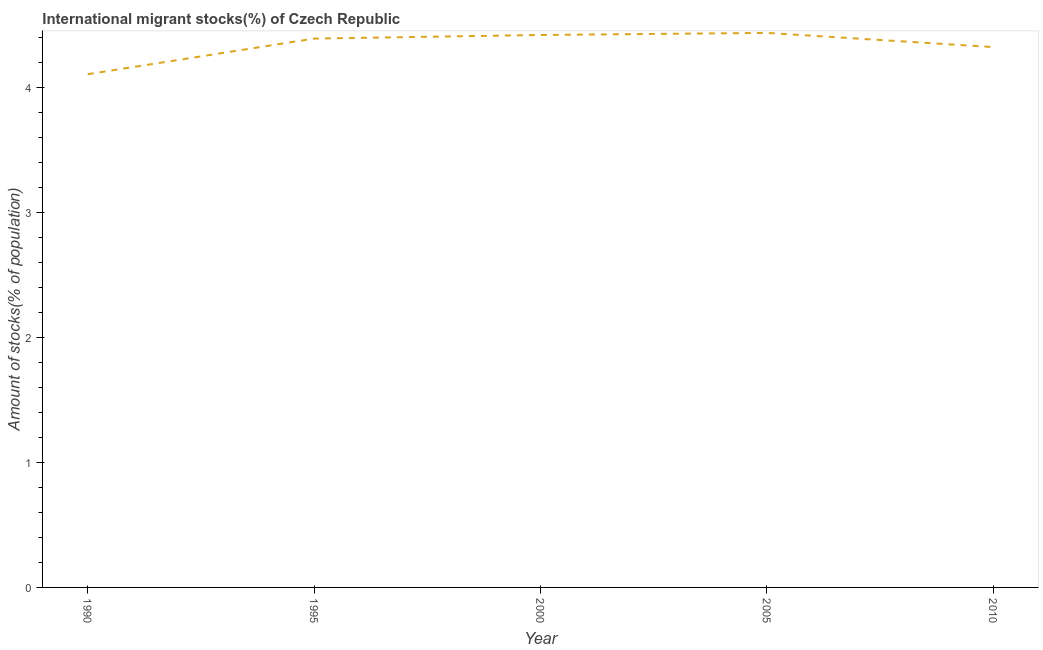What is the number of international migrant stocks in 2010?
Ensure brevity in your answer.  4.33. Across all years, what is the maximum number of international migrant stocks?
Offer a terse response. 4.44. Across all years, what is the minimum number of international migrant stocks?
Your answer should be compact. 4.11. In which year was the number of international migrant stocks minimum?
Offer a terse response. 1990. What is the sum of the number of international migrant stocks?
Ensure brevity in your answer.  21.69. What is the difference between the number of international migrant stocks in 2000 and 2005?
Offer a very short reply. -0.02. What is the average number of international migrant stocks per year?
Keep it short and to the point. 4.34. What is the median number of international migrant stocks?
Your response must be concise. 4.39. In how many years, is the number of international migrant stocks greater than 3 %?
Give a very brief answer. 5. Do a majority of the years between 2010 and 2005 (inclusive) have number of international migrant stocks greater than 1.8 %?
Provide a succinct answer. No. What is the ratio of the number of international migrant stocks in 1990 to that in 2000?
Your response must be concise. 0.93. Is the difference between the number of international migrant stocks in 1995 and 2005 greater than the difference between any two years?
Give a very brief answer. No. What is the difference between the highest and the second highest number of international migrant stocks?
Your answer should be very brief. 0.02. What is the difference between the highest and the lowest number of international migrant stocks?
Make the answer very short. 0.33. In how many years, is the number of international migrant stocks greater than the average number of international migrant stocks taken over all years?
Make the answer very short. 3. Does the number of international migrant stocks monotonically increase over the years?
Keep it short and to the point. No. How many lines are there?
Ensure brevity in your answer.  1. How many years are there in the graph?
Give a very brief answer. 5. Are the values on the major ticks of Y-axis written in scientific E-notation?
Provide a short and direct response. No. Does the graph contain any zero values?
Provide a succinct answer. No. What is the title of the graph?
Make the answer very short. International migrant stocks(%) of Czech Republic. What is the label or title of the Y-axis?
Offer a terse response. Amount of stocks(% of population). What is the Amount of stocks(% of population) of 1990?
Offer a terse response. 4.11. What is the Amount of stocks(% of population) of 1995?
Offer a very short reply. 4.39. What is the Amount of stocks(% of population) in 2000?
Keep it short and to the point. 4.42. What is the Amount of stocks(% of population) of 2005?
Your answer should be compact. 4.44. What is the Amount of stocks(% of population) in 2010?
Your answer should be compact. 4.33. What is the difference between the Amount of stocks(% of population) in 1990 and 1995?
Make the answer very short. -0.29. What is the difference between the Amount of stocks(% of population) in 1990 and 2000?
Offer a very short reply. -0.31. What is the difference between the Amount of stocks(% of population) in 1990 and 2005?
Your answer should be compact. -0.33. What is the difference between the Amount of stocks(% of population) in 1990 and 2010?
Your answer should be very brief. -0.22. What is the difference between the Amount of stocks(% of population) in 1995 and 2000?
Ensure brevity in your answer.  -0.03. What is the difference between the Amount of stocks(% of population) in 1995 and 2005?
Make the answer very short. -0.05. What is the difference between the Amount of stocks(% of population) in 1995 and 2010?
Your response must be concise. 0.07. What is the difference between the Amount of stocks(% of population) in 2000 and 2005?
Offer a very short reply. -0.02. What is the difference between the Amount of stocks(% of population) in 2000 and 2010?
Make the answer very short. 0.1. What is the difference between the Amount of stocks(% of population) in 2005 and 2010?
Keep it short and to the point. 0.11. What is the ratio of the Amount of stocks(% of population) in 1990 to that in 1995?
Ensure brevity in your answer.  0.94. What is the ratio of the Amount of stocks(% of population) in 1990 to that in 2000?
Keep it short and to the point. 0.93. What is the ratio of the Amount of stocks(% of population) in 1990 to that in 2005?
Your response must be concise. 0.93. What is the ratio of the Amount of stocks(% of population) in 1995 to that in 2005?
Make the answer very short. 0.99. 